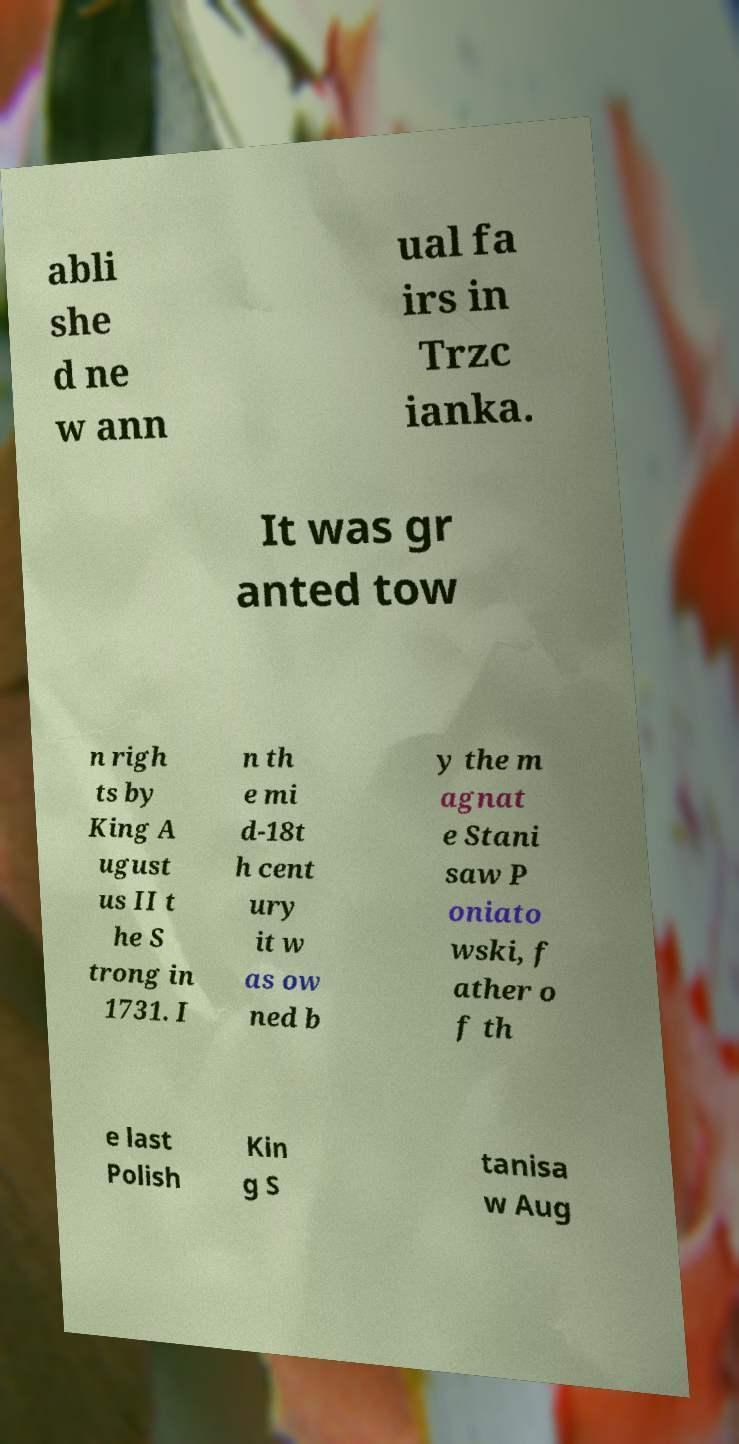Please identify and transcribe the text found in this image. abli she d ne w ann ual fa irs in Trzc ianka. It was gr anted tow n righ ts by King A ugust us II t he S trong in 1731. I n th e mi d-18t h cent ury it w as ow ned b y the m agnat e Stani saw P oniato wski, f ather o f th e last Polish Kin g S tanisa w Aug 